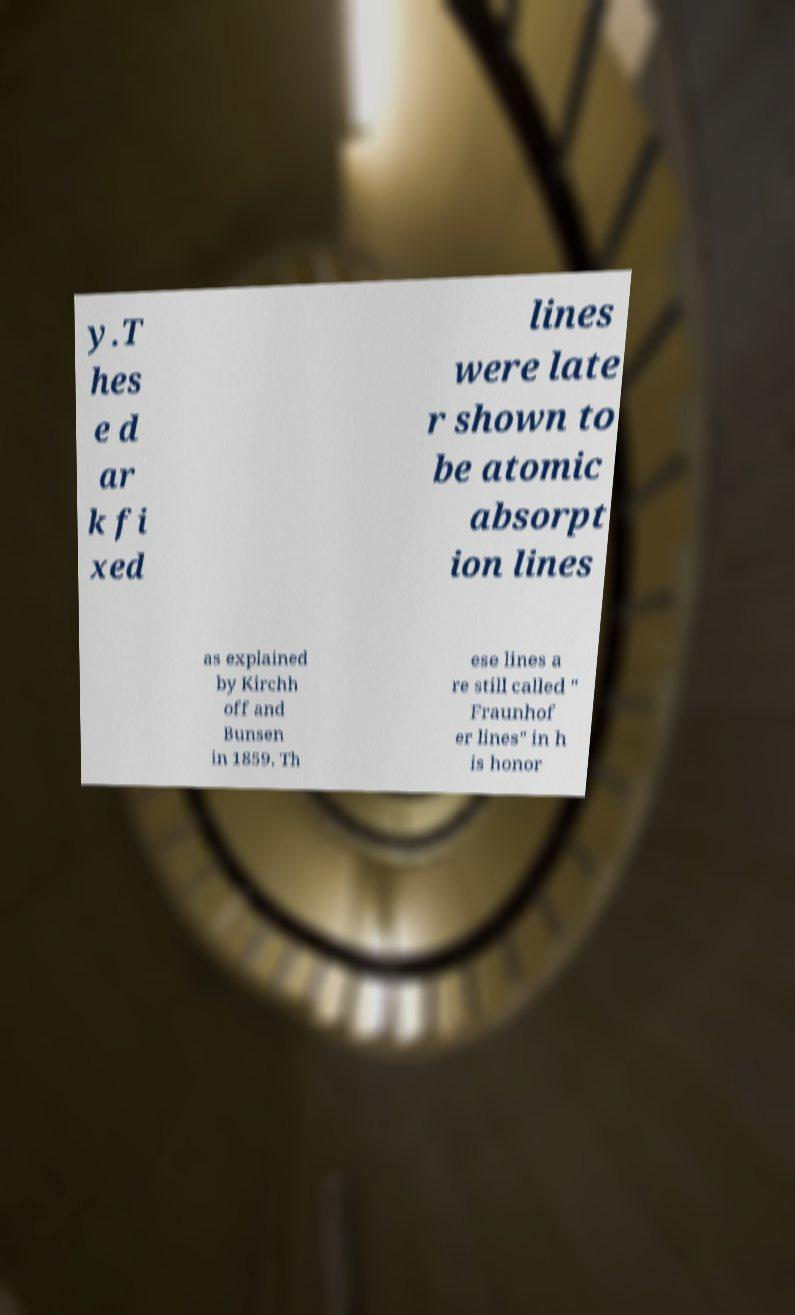Please read and relay the text visible in this image. What does it say? y.T hes e d ar k fi xed lines were late r shown to be atomic absorpt ion lines as explained by Kirchh off and Bunsen in 1859. Th ese lines a re still called " Fraunhof er lines" in h is honor 